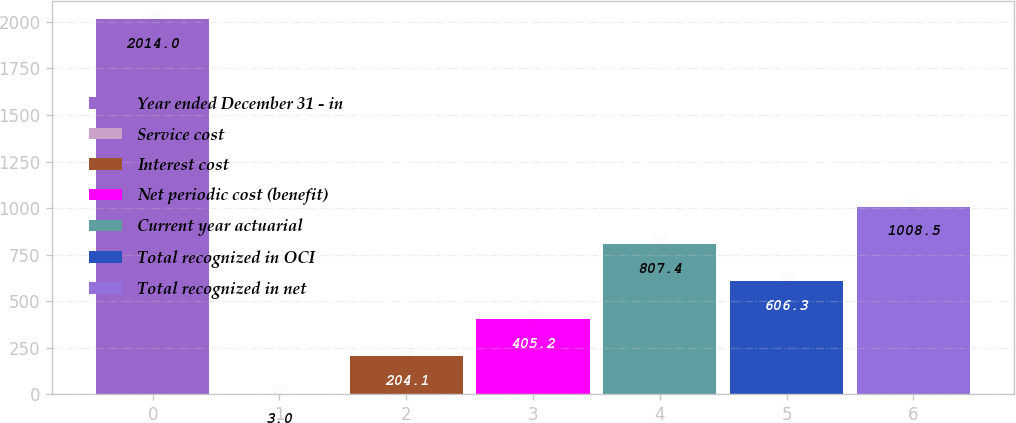Convert chart. <chart><loc_0><loc_0><loc_500><loc_500><bar_chart><fcel>Year ended December 31 - in<fcel>Service cost<fcel>Interest cost<fcel>Net periodic cost (benefit)<fcel>Current year actuarial<fcel>Total recognized in OCI<fcel>Total recognized in net<nl><fcel>2014<fcel>3<fcel>204.1<fcel>405.2<fcel>807.4<fcel>606.3<fcel>1008.5<nl></chart> 